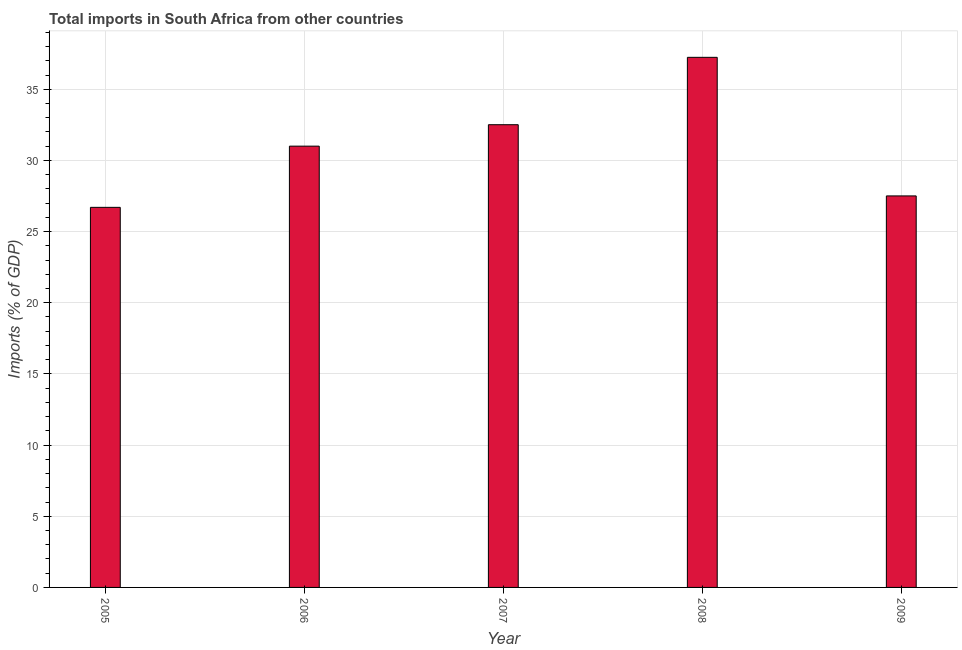Does the graph contain any zero values?
Provide a succinct answer. No. What is the title of the graph?
Your response must be concise. Total imports in South Africa from other countries. What is the label or title of the Y-axis?
Keep it short and to the point. Imports (% of GDP). What is the total imports in 2006?
Give a very brief answer. 31. Across all years, what is the maximum total imports?
Offer a very short reply. 37.24. Across all years, what is the minimum total imports?
Your answer should be very brief. 26.7. In which year was the total imports minimum?
Give a very brief answer. 2005. What is the sum of the total imports?
Ensure brevity in your answer.  154.96. What is the difference between the total imports in 2005 and 2009?
Keep it short and to the point. -0.8. What is the average total imports per year?
Give a very brief answer. 30.99. What is the median total imports?
Offer a terse response. 31. In how many years, is the total imports greater than 18 %?
Keep it short and to the point. 5. What is the ratio of the total imports in 2007 to that in 2009?
Ensure brevity in your answer.  1.18. Is the total imports in 2007 less than that in 2008?
Your response must be concise. Yes. What is the difference between the highest and the second highest total imports?
Keep it short and to the point. 4.73. Is the sum of the total imports in 2005 and 2009 greater than the maximum total imports across all years?
Your response must be concise. Yes. What is the difference between the highest and the lowest total imports?
Ensure brevity in your answer.  10.54. How many bars are there?
Offer a very short reply. 5. What is the Imports (% of GDP) of 2005?
Make the answer very short. 26.7. What is the Imports (% of GDP) in 2006?
Give a very brief answer. 31. What is the Imports (% of GDP) of 2007?
Keep it short and to the point. 32.51. What is the Imports (% of GDP) of 2008?
Your answer should be compact. 37.24. What is the Imports (% of GDP) of 2009?
Your response must be concise. 27.51. What is the difference between the Imports (% of GDP) in 2005 and 2006?
Provide a short and direct response. -4.3. What is the difference between the Imports (% of GDP) in 2005 and 2007?
Your answer should be compact. -5.81. What is the difference between the Imports (% of GDP) in 2005 and 2008?
Offer a very short reply. -10.54. What is the difference between the Imports (% of GDP) in 2005 and 2009?
Keep it short and to the point. -0.8. What is the difference between the Imports (% of GDP) in 2006 and 2007?
Your answer should be very brief. -1.51. What is the difference between the Imports (% of GDP) in 2006 and 2008?
Offer a very short reply. -6.24. What is the difference between the Imports (% of GDP) in 2006 and 2009?
Make the answer very short. 3.5. What is the difference between the Imports (% of GDP) in 2007 and 2008?
Give a very brief answer. -4.73. What is the difference between the Imports (% of GDP) in 2007 and 2009?
Ensure brevity in your answer.  5. What is the difference between the Imports (% of GDP) in 2008 and 2009?
Give a very brief answer. 9.74. What is the ratio of the Imports (% of GDP) in 2005 to that in 2006?
Give a very brief answer. 0.86. What is the ratio of the Imports (% of GDP) in 2005 to that in 2007?
Your answer should be compact. 0.82. What is the ratio of the Imports (% of GDP) in 2005 to that in 2008?
Give a very brief answer. 0.72. What is the ratio of the Imports (% of GDP) in 2005 to that in 2009?
Give a very brief answer. 0.97. What is the ratio of the Imports (% of GDP) in 2006 to that in 2007?
Make the answer very short. 0.95. What is the ratio of the Imports (% of GDP) in 2006 to that in 2008?
Provide a short and direct response. 0.83. What is the ratio of the Imports (% of GDP) in 2006 to that in 2009?
Offer a terse response. 1.13. What is the ratio of the Imports (% of GDP) in 2007 to that in 2008?
Offer a very short reply. 0.87. What is the ratio of the Imports (% of GDP) in 2007 to that in 2009?
Offer a terse response. 1.18. What is the ratio of the Imports (% of GDP) in 2008 to that in 2009?
Your answer should be very brief. 1.35. 